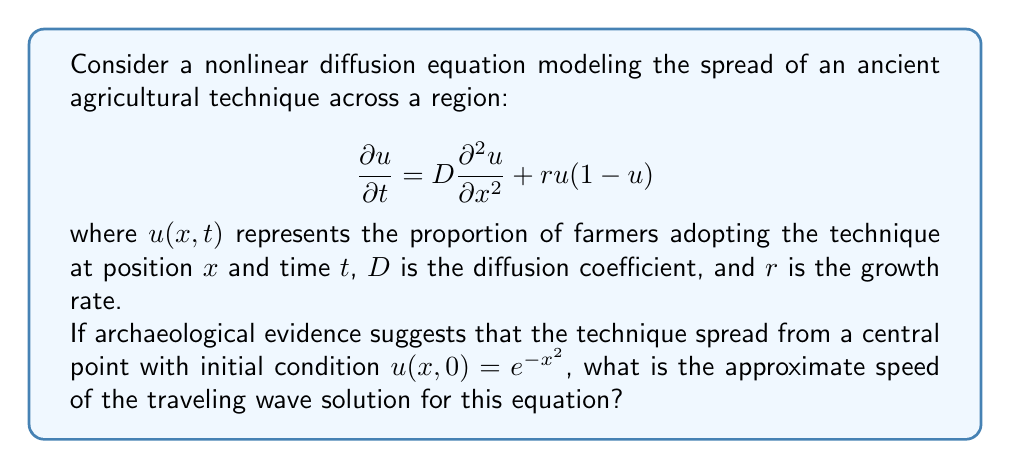Provide a solution to this math problem. To find the speed of the traveling wave solution, we'll follow these steps:

1) For a nonlinear diffusion equation of the form:
   $$\frac{\partial u}{\partial t} = D\frac{\partial^2 u}{\partial x^2} + f(u)$$
   where $f(u) = ru(1-u)$ in this case, the speed of the traveling wave is given by:
   $$c = 2\sqrt{Df'(0)}$$

2) Calculate $f'(u)$:
   $$f'(u) = r(1-u) - ru = r(1-2u)$$

3) Evaluate $f'(0)$:
   $$f'(0) = r(1-2(0)) = r$$

4) Substitute into the speed formula:
   $$c = 2\sqrt{Dr}$$

5) This gives us the approximate speed of the traveling wave solution.

Note: The initial condition $u(x,0) = e^{-x^2}$ confirms that the technique spreads from a central point (x=0), which is consistent with a traveling wave solution. However, the exact initial condition doesn't affect the asymptotic speed of the wave.
Answer: $2\sqrt{Dr}$ 